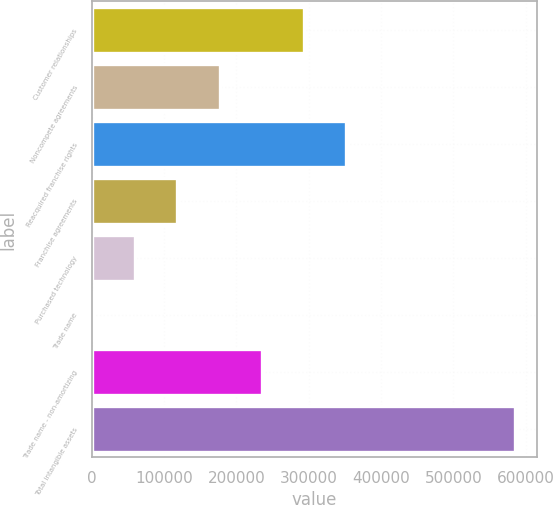Convert chart. <chart><loc_0><loc_0><loc_500><loc_500><bar_chart><fcel>Customer relationships<fcel>Noncompete agreements<fcel>Reacquired franchise rights<fcel>Franchise agreements<fcel>Purchased technology<fcel>Trade name<fcel>Trade name - non-amortizing<fcel>Total intangible assets<nl><fcel>293664<fcel>176729<fcel>352132<fcel>118261<fcel>59792.9<fcel>1325<fcel>235197<fcel>586004<nl></chart> 